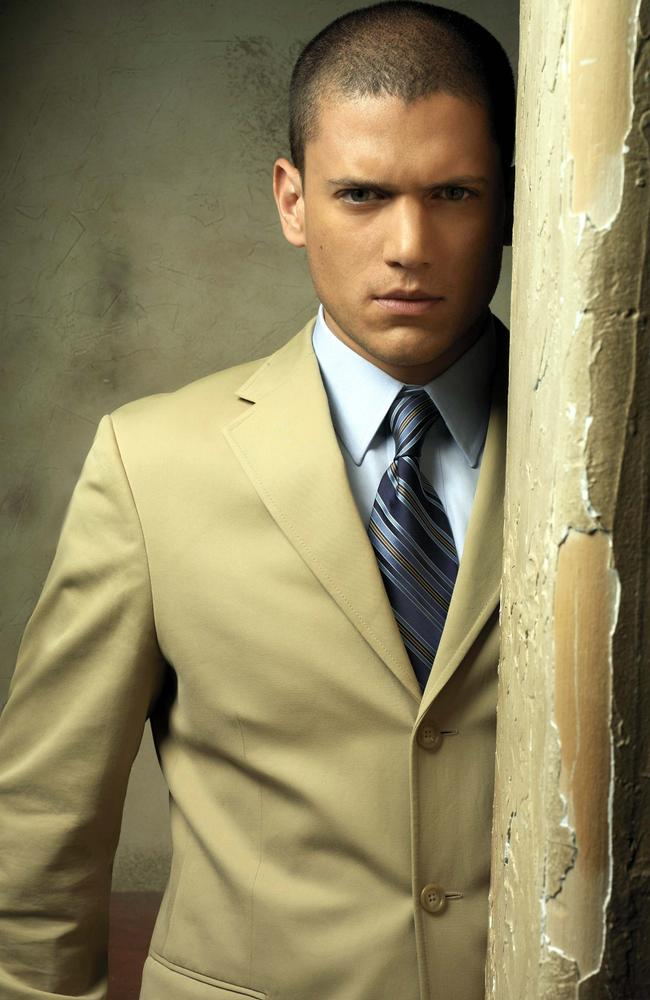Imagine this image is a scene from a high-stakes drama. Describe what's going on. In the midst of an unfolding criminal investigation, Detective Miller stands resolute, leaning against the textured wall of an abandoned warehouse. His beige suit, impeccably tailored, starkly contrasts the decay around him. The peeling paint on the wall is a silent witness to the gritty realities he faces daily. Behind those intense eyes lies a mind racing to connect the dots of a case that could bring a notorious crime syndicate to its knees. The tension in the air is palpable as he prepares to confront a key witness hiding somewhere within the dilapidated structure. Each moment is critical, as the clock ticks towards a confrontation that promises to be a defining moment in his career.  Michael Scofield in another escape plan. What's the context of this image? In a subplot of 'Prison Break,' Michael Scofield, wearing his tailored beige suit for a rare public meeting, finds himself moments away from executing another complex escape plan. The peeling paint wall he's leaning against is part of an old courthouse, long since abandoned and scheduled for demolition. Michael's serious and focused gaze shows that he's in deep thought, strategizing the next steps to rescue a wrongly accused prisoner. The backdrop symbolizes the fading veneer of justice he constantly fights against. The contrasting elements in the scene capture the tension of his double life - one moment a sophisticated public figure, the next, a master strategist orchestrating yet another daring escape. 